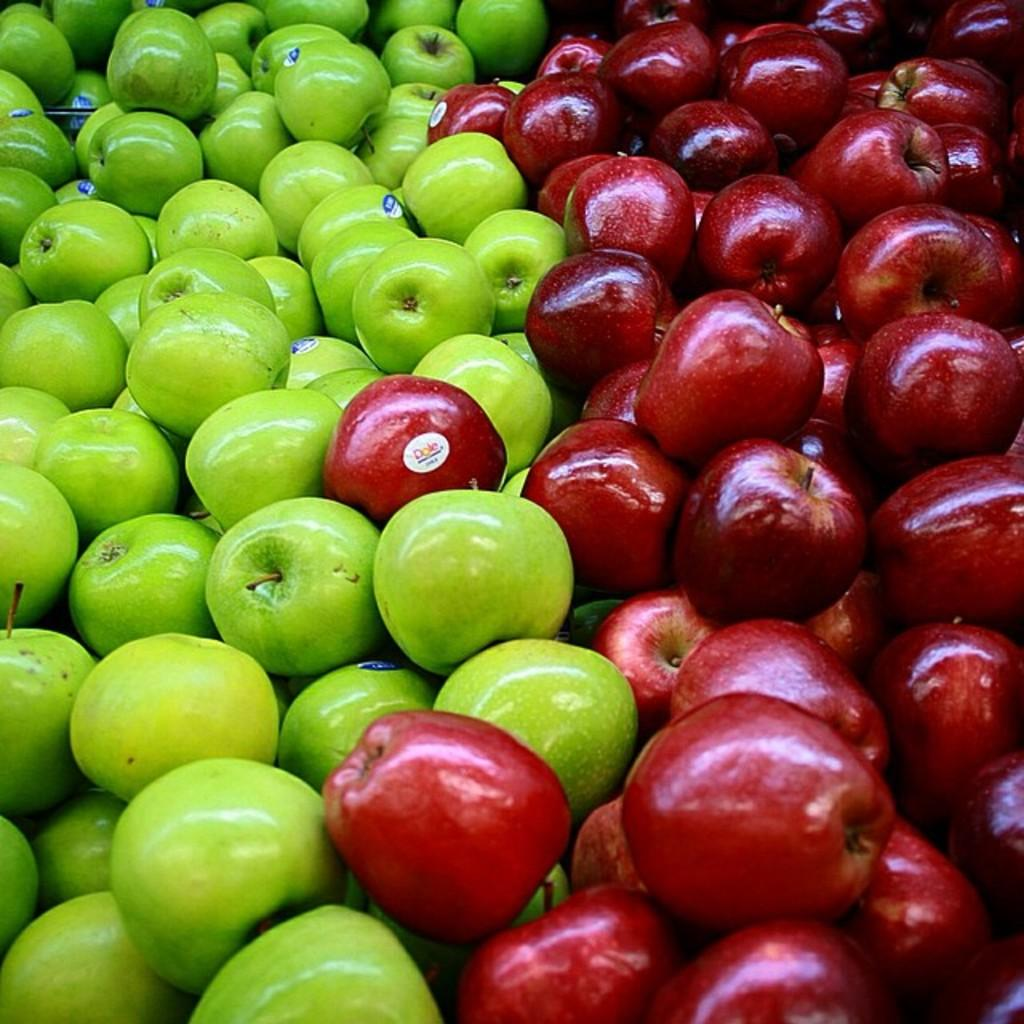What type of fruit is predominantly featured in the image? There are many apples in the image. Can you describe the color of some of the apples? Some of the apples are green. What is present on the surface of the apples? There are stickers on the apples. Are there any pears visible in the image? There are no pears present in the image; it only features apples. Can you see any toys or horses in the image? There are no toys or horses visible in the image? 